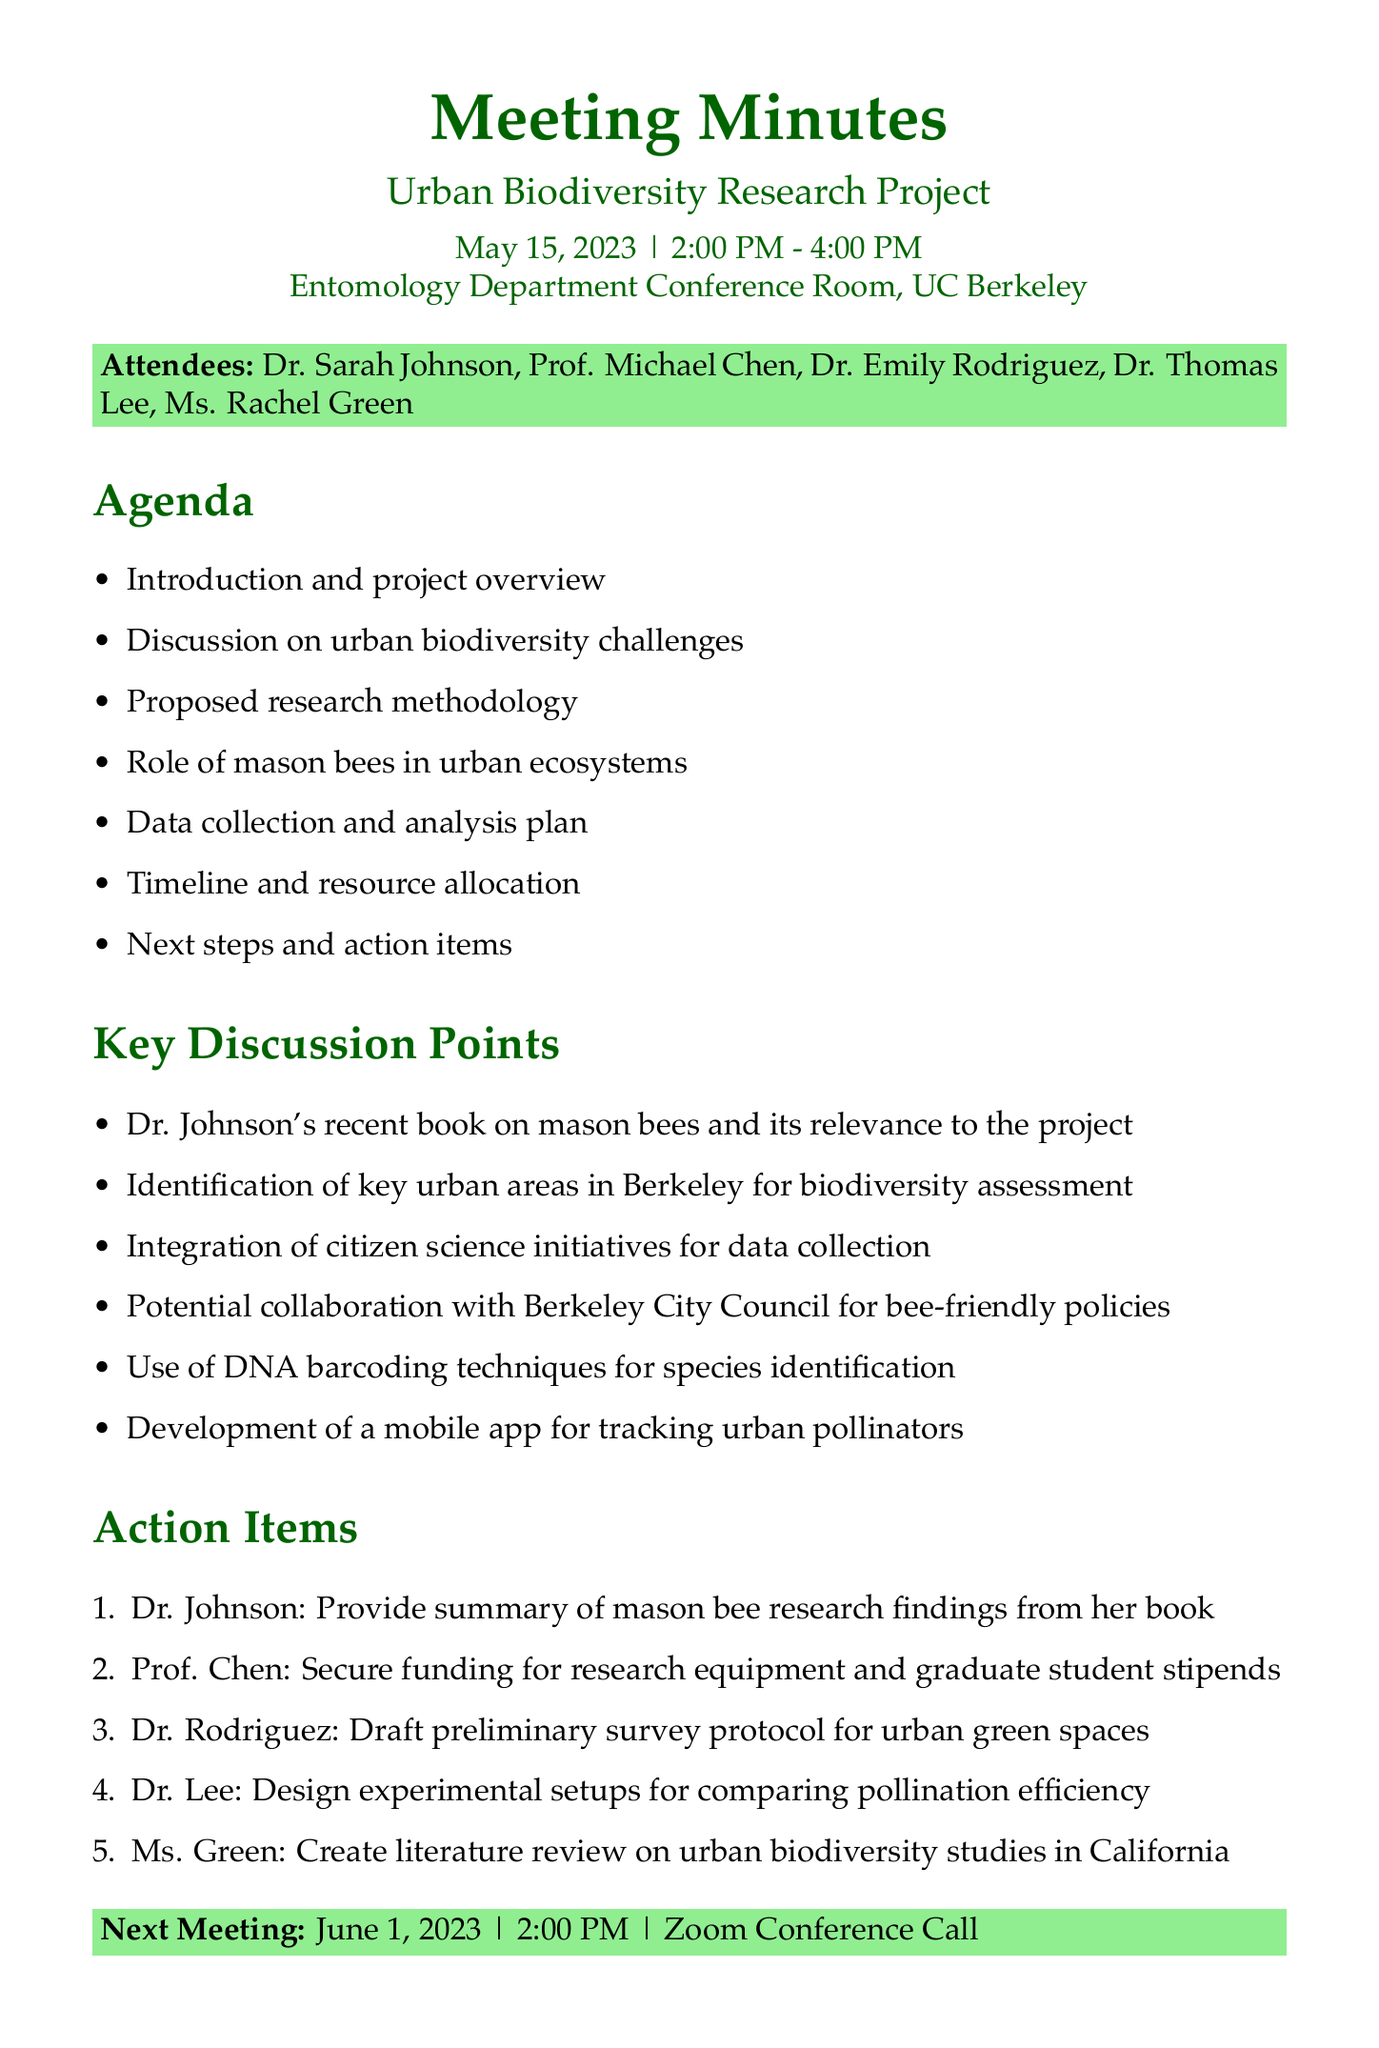What was the date of the meeting? The date of the meeting is specified in the document header as May 15, 2023.
Answer: May 15, 2023 Who is the head of the Entomology Department? The document lists Prof. Michael Chen as the head of the Entomology Department.
Answer: Prof. Michael Chen What is one proposed research methodology discussed in the meeting? The minutes mention the use of DNA barcoding techniques for species identification as a proposed methodology.
Answer: DNA barcoding How long was the meeting scheduled to last? The meeting time is stated as 2:00 PM - 4:00 PM, indicating it was scheduled to last for two hours.
Answer: Two hours What is the next meeting date? The next meeting date is noted in the document as June 1, 2023.
Answer: June 1, 2023 Who is responsible for creating a literature review? According to the action items, Ms. Rachel Green is responsible for creating a literature review.
Answer: Ms. Rachel Green Why is citizen science mentioned in the discussion points? The integration of citizen science initiatives for data collection was discussed, emphasizing community involvement in the research project.
Answer: Community involvement How many attendees were present at the meeting? The document lists a total of five attendees, which comprises the participants present during the meeting.
Answer: Five attendees 